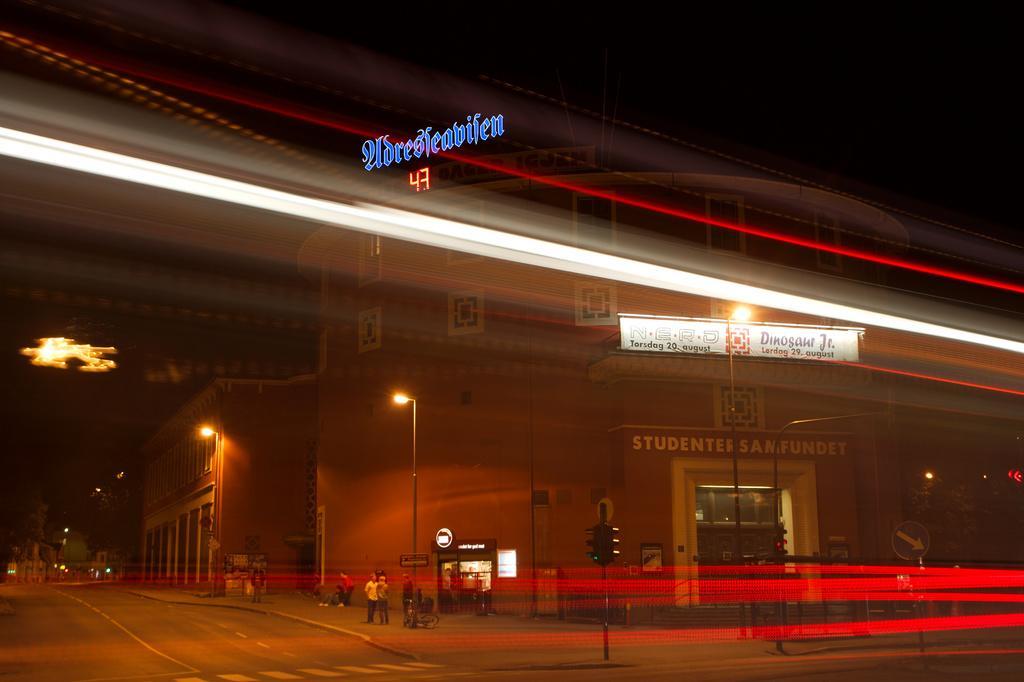Describe this image in one or two sentences. In the foreground of the image we can see a group of people standing on the ground, light poles, traffic lights. In the center of the image we can see a group of buildings with sign boards and some text. In the background, we can see the sky. 